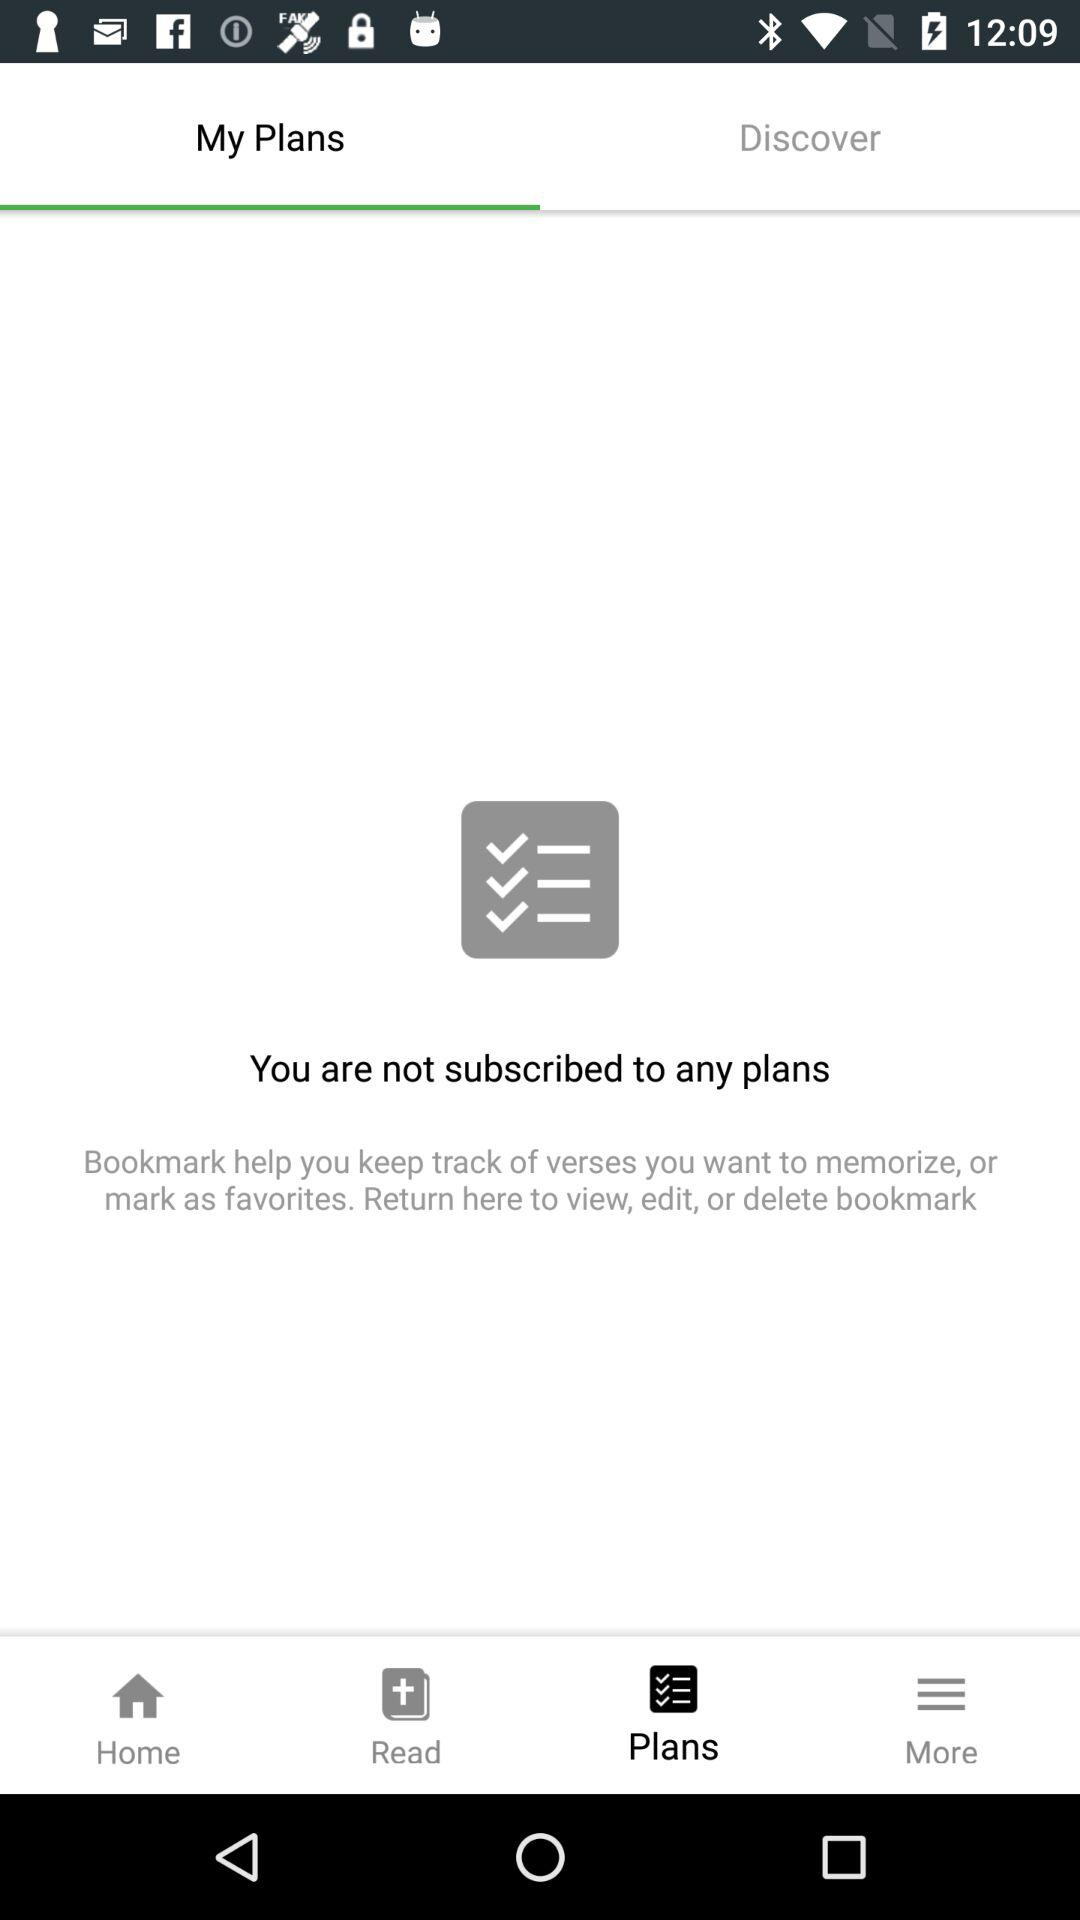How many plans do I have?
Answer the question using a single word or phrase. 0 